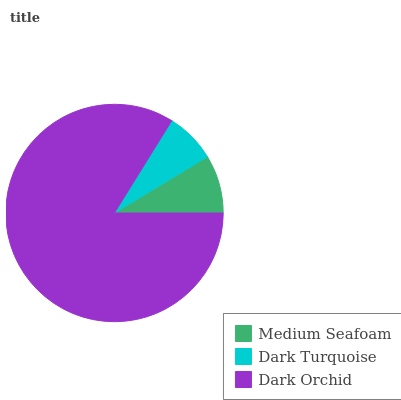Is Dark Turquoise the minimum?
Answer yes or no. Yes. Is Dark Orchid the maximum?
Answer yes or no. Yes. Is Dark Orchid the minimum?
Answer yes or no. No. Is Dark Turquoise the maximum?
Answer yes or no. No. Is Dark Orchid greater than Dark Turquoise?
Answer yes or no. Yes. Is Dark Turquoise less than Dark Orchid?
Answer yes or no. Yes. Is Dark Turquoise greater than Dark Orchid?
Answer yes or no. No. Is Dark Orchid less than Dark Turquoise?
Answer yes or no. No. Is Medium Seafoam the high median?
Answer yes or no. Yes. Is Medium Seafoam the low median?
Answer yes or no. Yes. Is Dark Orchid the high median?
Answer yes or no. No. Is Dark Turquoise the low median?
Answer yes or no. No. 